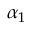Convert formula to latex. <formula><loc_0><loc_0><loc_500><loc_500>\alpha _ { 1 }</formula> 